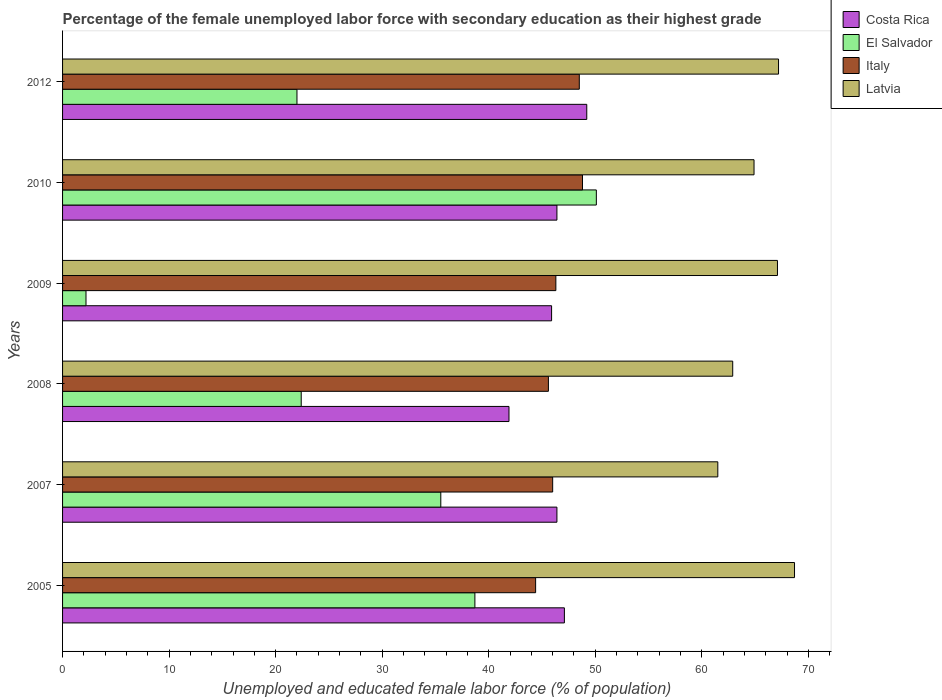Are the number of bars per tick equal to the number of legend labels?
Your answer should be very brief. Yes. What is the percentage of the unemployed female labor force with secondary education in El Salvador in 2007?
Provide a short and direct response. 35.5. Across all years, what is the maximum percentage of the unemployed female labor force with secondary education in Costa Rica?
Your answer should be compact. 49.2. Across all years, what is the minimum percentage of the unemployed female labor force with secondary education in El Salvador?
Provide a succinct answer. 2.2. In which year was the percentage of the unemployed female labor force with secondary education in Latvia maximum?
Offer a terse response. 2005. In which year was the percentage of the unemployed female labor force with secondary education in El Salvador minimum?
Your answer should be compact. 2009. What is the total percentage of the unemployed female labor force with secondary education in Italy in the graph?
Ensure brevity in your answer.  279.6. What is the difference between the percentage of the unemployed female labor force with secondary education in El Salvador in 2007 and that in 2010?
Your answer should be compact. -14.6. What is the difference between the percentage of the unemployed female labor force with secondary education in Latvia in 2010 and the percentage of the unemployed female labor force with secondary education in El Salvador in 2007?
Offer a very short reply. 29.4. What is the average percentage of the unemployed female labor force with secondary education in Costa Rica per year?
Offer a terse response. 46.15. In the year 2007, what is the difference between the percentage of the unemployed female labor force with secondary education in Latvia and percentage of the unemployed female labor force with secondary education in Italy?
Make the answer very short. 15.5. What is the ratio of the percentage of the unemployed female labor force with secondary education in El Salvador in 2005 to that in 2007?
Ensure brevity in your answer.  1.09. Is the percentage of the unemployed female labor force with secondary education in El Salvador in 2010 less than that in 2012?
Provide a succinct answer. No. Is the difference between the percentage of the unemployed female labor force with secondary education in Latvia in 2010 and 2012 greater than the difference between the percentage of the unemployed female labor force with secondary education in Italy in 2010 and 2012?
Offer a terse response. No. What is the difference between the highest and the second highest percentage of the unemployed female labor force with secondary education in Italy?
Your response must be concise. 0.3. What is the difference between the highest and the lowest percentage of the unemployed female labor force with secondary education in El Salvador?
Provide a short and direct response. 47.9. Is the sum of the percentage of the unemployed female labor force with secondary education in Italy in 2009 and 2012 greater than the maximum percentage of the unemployed female labor force with secondary education in Costa Rica across all years?
Your answer should be very brief. Yes. Is it the case that in every year, the sum of the percentage of the unemployed female labor force with secondary education in Costa Rica and percentage of the unemployed female labor force with secondary education in Italy is greater than the sum of percentage of the unemployed female labor force with secondary education in El Salvador and percentage of the unemployed female labor force with secondary education in Latvia?
Your answer should be very brief. No. What does the 3rd bar from the top in 2007 represents?
Give a very brief answer. El Salvador. What does the 4th bar from the bottom in 2007 represents?
Offer a terse response. Latvia. How many bars are there?
Offer a very short reply. 24. What is the difference between two consecutive major ticks on the X-axis?
Give a very brief answer. 10. Are the values on the major ticks of X-axis written in scientific E-notation?
Give a very brief answer. No. How many legend labels are there?
Your response must be concise. 4. What is the title of the graph?
Ensure brevity in your answer.  Percentage of the female unemployed labor force with secondary education as their highest grade. Does "Seychelles" appear as one of the legend labels in the graph?
Give a very brief answer. No. What is the label or title of the X-axis?
Your response must be concise. Unemployed and educated female labor force (% of population). What is the Unemployed and educated female labor force (% of population) of Costa Rica in 2005?
Your answer should be very brief. 47.1. What is the Unemployed and educated female labor force (% of population) in El Salvador in 2005?
Your answer should be very brief. 38.7. What is the Unemployed and educated female labor force (% of population) in Italy in 2005?
Your answer should be compact. 44.4. What is the Unemployed and educated female labor force (% of population) of Latvia in 2005?
Your response must be concise. 68.7. What is the Unemployed and educated female labor force (% of population) of Costa Rica in 2007?
Your answer should be compact. 46.4. What is the Unemployed and educated female labor force (% of population) of El Salvador in 2007?
Give a very brief answer. 35.5. What is the Unemployed and educated female labor force (% of population) of Italy in 2007?
Your answer should be compact. 46. What is the Unemployed and educated female labor force (% of population) in Latvia in 2007?
Keep it short and to the point. 61.5. What is the Unemployed and educated female labor force (% of population) of Costa Rica in 2008?
Your answer should be very brief. 41.9. What is the Unemployed and educated female labor force (% of population) in El Salvador in 2008?
Your answer should be compact. 22.4. What is the Unemployed and educated female labor force (% of population) in Italy in 2008?
Your answer should be compact. 45.6. What is the Unemployed and educated female labor force (% of population) in Latvia in 2008?
Keep it short and to the point. 62.9. What is the Unemployed and educated female labor force (% of population) in Costa Rica in 2009?
Ensure brevity in your answer.  45.9. What is the Unemployed and educated female labor force (% of population) in El Salvador in 2009?
Give a very brief answer. 2.2. What is the Unemployed and educated female labor force (% of population) of Italy in 2009?
Provide a succinct answer. 46.3. What is the Unemployed and educated female labor force (% of population) in Latvia in 2009?
Your answer should be compact. 67.1. What is the Unemployed and educated female labor force (% of population) in Costa Rica in 2010?
Keep it short and to the point. 46.4. What is the Unemployed and educated female labor force (% of population) in El Salvador in 2010?
Your answer should be compact. 50.1. What is the Unemployed and educated female labor force (% of population) of Italy in 2010?
Provide a short and direct response. 48.8. What is the Unemployed and educated female labor force (% of population) in Latvia in 2010?
Your answer should be very brief. 64.9. What is the Unemployed and educated female labor force (% of population) of Costa Rica in 2012?
Give a very brief answer. 49.2. What is the Unemployed and educated female labor force (% of population) in El Salvador in 2012?
Give a very brief answer. 22. What is the Unemployed and educated female labor force (% of population) in Italy in 2012?
Ensure brevity in your answer.  48.5. What is the Unemployed and educated female labor force (% of population) in Latvia in 2012?
Your answer should be very brief. 67.2. Across all years, what is the maximum Unemployed and educated female labor force (% of population) in Costa Rica?
Offer a very short reply. 49.2. Across all years, what is the maximum Unemployed and educated female labor force (% of population) in El Salvador?
Your response must be concise. 50.1. Across all years, what is the maximum Unemployed and educated female labor force (% of population) in Italy?
Keep it short and to the point. 48.8. Across all years, what is the maximum Unemployed and educated female labor force (% of population) in Latvia?
Your response must be concise. 68.7. Across all years, what is the minimum Unemployed and educated female labor force (% of population) of Costa Rica?
Your response must be concise. 41.9. Across all years, what is the minimum Unemployed and educated female labor force (% of population) of El Salvador?
Your answer should be very brief. 2.2. Across all years, what is the minimum Unemployed and educated female labor force (% of population) in Italy?
Make the answer very short. 44.4. Across all years, what is the minimum Unemployed and educated female labor force (% of population) in Latvia?
Your response must be concise. 61.5. What is the total Unemployed and educated female labor force (% of population) in Costa Rica in the graph?
Your answer should be compact. 276.9. What is the total Unemployed and educated female labor force (% of population) in El Salvador in the graph?
Offer a terse response. 170.9. What is the total Unemployed and educated female labor force (% of population) in Italy in the graph?
Your answer should be very brief. 279.6. What is the total Unemployed and educated female labor force (% of population) of Latvia in the graph?
Offer a terse response. 392.3. What is the difference between the Unemployed and educated female labor force (% of population) in Costa Rica in 2005 and that in 2007?
Offer a terse response. 0.7. What is the difference between the Unemployed and educated female labor force (% of population) of Italy in 2005 and that in 2007?
Keep it short and to the point. -1.6. What is the difference between the Unemployed and educated female labor force (% of population) in El Salvador in 2005 and that in 2008?
Make the answer very short. 16.3. What is the difference between the Unemployed and educated female labor force (% of population) in El Salvador in 2005 and that in 2009?
Ensure brevity in your answer.  36.5. What is the difference between the Unemployed and educated female labor force (% of population) in Italy in 2005 and that in 2009?
Your answer should be compact. -1.9. What is the difference between the Unemployed and educated female labor force (% of population) in Italy in 2005 and that in 2010?
Offer a very short reply. -4.4. What is the difference between the Unemployed and educated female labor force (% of population) in Italy in 2007 and that in 2008?
Provide a succinct answer. 0.4. What is the difference between the Unemployed and educated female labor force (% of population) of Costa Rica in 2007 and that in 2009?
Provide a succinct answer. 0.5. What is the difference between the Unemployed and educated female labor force (% of population) in El Salvador in 2007 and that in 2009?
Your answer should be compact. 33.3. What is the difference between the Unemployed and educated female labor force (% of population) in Costa Rica in 2007 and that in 2010?
Your answer should be compact. 0. What is the difference between the Unemployed and educated female labor force (% of population) of El Salvador in 2007 and that in 2010?
Your answer should be very brief. -14.6. What is the difference between the Unemployed and educated female labor force (% of population) of Costa Rica in 2007 and that in 2012?
Your answer should be compact. -2.8. What is the difference between the Unemployed and educated female labor force (% of population) in Italy in 2007 and that in 2012?
Keep it short and to the point. -2.5. What is the difference between the Unemployed and educated female labor force (% of population) in El Salvador in 2008 and that in 2009?
Your answer should be very brief. 20.2. What is the difference between the Unemployed and educated female labor force (% of population) of El Salvador in 2008 and that in 2010?
Give a very brief answer. -27.7. What is the difference between the Unemployed and educated female labor force (% of population) in El Salvador in 2008 and that in 2012?
Offer a terse response. 0.4. What is the difference between the Unemployed and educated female labor force (% of population) in Italy in 2008 and that in 2012?
Your answer should be compact. -2.9. What is the difference between the Unemployed and educated female labor force (% of population) of Latvia in 2008 and that in 2012?
Make the answer very short. -4.3. What is the difference between the Unemployed and educated female labor force (% of population) of El Salvador in 2009 and that in 2010?
Your answer should be compact. -47.9. What is the difference between the Unemployed and educated female labor force (% of population) in El Salvador in 2009 and that in 2012?
Your response must be concise. -19.8. What is the difference between the Unemployed and educated female labor force (% of population) in Latvia in 2009 and that in 2012?
Offer a very short reply. -0.1. What is the difference between the Unemployed and educated female labor force (% of population) in Costa Rica in 2010 and that in 2012?
Your answer should be compact. -2.8. What is the difference between the Unemployed and educated female labor force (% of population) in El Salvador in 2010 and that in 2012?
Your answer should be compact. 28.1. What is the difference between the Unemployed and educated female labor force (% of population) in Italy in 2010 and that in 2012?
Give a very brief answer. 0.3. What is the difference between the Unemployed and educated female labor force (% of population) in Costa Rica in 2005 and the Unemployed and educated female labor force (% of population) in El Salvador in 2007?
Your response must be concise. 11.6. What is the difference between the Unemployed and educated female labor force (% of population) in Costa Rica in 2005 and the Unemployed and educated female labor force (% of population) in Italy in 2007?
Your response must be concise. 1.1. What is the difference between the Unemployed and educated female labor force (% of population) in Costa Rica in 2005 and the Unemployed and educated female labor force (% of population) in Latvia in 2007?
Provide a short and direct response. -14.4. What is the difference between the Unemployed and educated female labor force (% of population) in El Salvador in 2005 and the Unemployed and educated female labor force (% of population) in Italy in 2007?
Your response must be concise. -7.3. What is the difference between the Unemployed and educated female labor force (% of population) in El Salvador in 2005 and the Unemployed and educated female labor force (% of population) in Latvia in 2007?
Provide a short and direct response. -22.8. What is the difference between the Unemployed and educated female labor force (% of population) of Italy in 2005 and the Unemployed and educated female labor force (% of population) of Latvia in 2007?
Your answer should be very brief. -17.1. What is the difference between the Unemployed and educated female labor force (% of population) of Costa Rica in 2005 and the Unemployed and educated female labor force (% of population) of El Salvador in 2008?
Keep it short and to the point. 24.7. What is the difference between the Unemployed and educated female labor force (% of population) in Costa Rica in 2005 and the Unemployed and educated female labor force (% of population) in Latvia in 2008?
Offer a very short reply. -15.8. What is the difference between the Unemployed and educated female labor force (% of population) of El Salvador in 2005 and the Unemployed and educated female labor force (% of population) of Latvia in 2008?
Keep it short and to the point. -24.2. What is the difference between the Unemployed and educated female labor force (% of population) in Italy in 2005 and the Unemployed and educated female labor force (% of population) in Latvia in 2008?
Give a very brief answer. -18.5. What is the difference between the Unemployed and educated female labor force (% of population) of Costa Rica in 2005 and the Unemployed and educated female labor force (% of population) of El Salvador in 2009?
Ensure brevity in your answer.  44.9. What is the difference between the Unemployed and educated female labor force (% of population) in Costa Rica in 2005 and the Unemployed and educated female labor force (% of population) in Italy in 2009?
Make the answer very short. 0.8. What is the difference between the Unemployed and educated female labor force (% of population) of Costa Rica in 2005 and the Unemployed and educated female labor force (% of population) of Latvia in 2009?
Give a very brief answer. -20. What is the difference between the Unemployed and educated female labor force (% of population) in El Salvador in 2005 and the Unemployed and educated female labor force (% of population) in Latvia in 2009?
Offer a terse response. -28.4. What is the difference between the Unemployed and educated female labor force (% of population) in Italy in 2005 and the Unemployed and educated female labor force (% of population) in Latvia in 2009?
Give a very brief answer. -22.7. What is the difference between the Unemployed and educated female labor force (% of population) in Costa Rica in 2005 and the Unemployed and educated female labor force (% of population) in Latvia in 2010?
Offer a terse response. -17.8. What is the difference between the Unemployed and educated female labor force (% of population) of El Salvador in 2005 and the Unemployed and educated female labor force (% of population) of Latvia in 2010?
Ensure brevity in your answer.  -26.2. What is the difference between the Unemployed and educated female labor force (% of population) in Italy in 2005 and the Unemployed and educated female labor force (% of population) in Latvia in 2010?
Give a very brief answer. -20.5. What is the difference between the Unemployed and educated female labor force (% of population) of Costa Rica in 2005 and the Unemployed and educated female labor force (% of population) of El Salvador in 2012?
Your answer should be very brief. 25.1. What is the difference between the Unemployed and educated female labor force (% of population) in Costa Rica in 2005 and the Unemployed and educated female labor force (% of population) in Italy in 2012?
Provide a succinct answer. -1.4. What is the difference between the Unemployed and educated female labor force (% of population) of Costa Rica in 2005 and the Unemployed and educated female labor force (% of population) of Latvia in 2012?
Offer a very short reply. -20.1. What is the difference between the Unemployed and educated female labor force (% of population) of El Salvador in 2005 and the Unemployed and educated female labor force (% of population) of Latvia in 2012?
Provide a succinct answer. -28.5. What is the difference between the Unemployed and educated female labor force (% of population) in Italy in 2005 and the Unemployed and educated female labor force (% of population) in Latvia in 2012?
Provide a short and direct response. -22.8. What is the difference between the Unemployed and educated female labor force (% of population) of Costa Rica in 2007 and the Unemployed and educated female labor force (% of population) of Italy in 2008?
Your answer should be very brief. 0.8. What is the difference between the Unemployed and educated female labor force (% of population) in Costa Rica in 2007 and the Unemployed and educated female labor force (% of population) in Latvia in 2008?
Your answer should be very brief. -16.5. What is the difference between the Unemployed and educated female labor force (% of population) in El Salvador in 2007 and the Unemployed and educated female labor force (% of population) in Latvia in 2008?
Your answer should be very brief. -27.4. What is the difference between the Unemployed and educated female labor force (% of population) of Italy in 2007 and the Unemployed and educated female labor force (% of population) of Latvia in 2008?
Your answer should be compact. -16.9. What is the difference between the Unemployed and educated female labor force (% of population) in Costa Rica in 2007 and the Unemployed and educated female labor force (% of population) in El Salvador in 2009?
Provide a short and direct response. 44.2. What is the difference between the Unemployed and educated female labor force (% of population) in Costa Rica in 2007 and the Unemployed and educated female labor force (% of population) in Latvia in 2009?
Keep it short and to the point. -20.7. What is the difference between the Unemployed and educated female labor force (% of population) of El Salvador in 2007 and the Unemployed and educated female labor force (% of population) of Italy in 2009?
Provide a succinct answer. -10.8. What is the difference between the Unemployed and educated female labor force (% of population) of El Salvador in 2007 and the Unemployed and educated female labor force (% of population) of Latvia in 2009?
Offer a terse response. -31.6. What is the difference between the Unemployed and educated female labor force (% of population) in Italy in 2007 and the Unemployed and educated female labor force (% of population) in Latvia in 2009?
Your answer should be compact. -21.1. What is the difference between the Unemployed and educated female labor force (% of population) in Costa Rica in 2007 and the Unemployed and educated female labor force (% of population) in El Salvador in 2010?
Offer a very short reply. -3.7. What is the difference between the Unemployed and educated female labor force (% of population) in Costa Rica in 2007 and the Unemployed and educated female labor force (% of population) in Latvia in 2010?
Your response must be concise. -18.5. What is the difference between the Unemployed and educated female labor force (% of population) in El Salvador in 2007 and the Unemployed and educated female labor force (% of population) in Latvia in 2010?
Make the answer very short. -29.4. What is the difference between the Unemployed and educated female labor force (% of population) of Italy in 2007 and the Unemployed and educated female labor force (% of population) of Latvia in 2010?
Your answer should be compact. -18.9. What is the difference between the Unemployed and educated female labor force (% of population) in Costa Rica in 2007 and the Unemployed and educated female labor force (% of population) in El Salvador in 2012?
Give a very brief answer. 24.4. What is the difference between the Unemployed and educated female labor force (% of population) in Costa Rica in 2007 and the Unemployed and educated female labor force (% of population) in Latvia in 2012?
Give a very brief answer. -20.8. What is the difference between the Unemployed and educated female labor force (% of population) in El Salvador in 2007 and the Unemployed and educated female labor force (% of population) in Italy in 2012?
Your answer should be very brief. -13. What is the difference between the Unemployed and educated female labor force (% of population) in El Salvador in 2007 and the Unemployed and educated female labor force (% of population) in Latvia in 2012?
Give a very brief answer. -31.7. What is the difference between the Unemployed and educated female labor force (% of population) of Italy in 2007 and the Unemployed and educated female labor force (% of population) of Latvia in 2012?
Offer a very short reply. -21.2. What is the difference between the Unemployed and educated female labor force (% of population) in Costa Rica in 2008 and the Unemployed and educated female labor force (% of population) in El Salvador in 2009?
Make the answer very short. 39.7. What is the difference between the Unemployed and educated female labor force (% of population) of Costa Rica in 2008 and the Unemployed and educated female labor force (% of population) of Latvia in 2009?
Your answer should be compact. -25.2. What is the difference between the Unemployed and educated female labor force (% of population) in El Salvador in 2008 and the Unemployed and educated female labor force (% of population) in Italy in 2009?
Your response must be concise. -23.9. What is the difference between the Unemployed and educated female labor force (% of population) of El Salvador in 2008 and the Unemployed and educated female labor force (% of population) of Latvia in 2009?
Ensure brevity in your answer.  -44.7. What is the difference between the Unemployed and educated female labor force (% of population) in Italy in 2008 and the Unemployed and educated female labor force (% of population) in Latvia in 2009?
Your answer should be compact. -21.5. What is the difference between the Unemployed and educated female labor force (% of population) in Costa Rica in 2008 and the Unemployed and educated female labor force (% of population) in El Salvador in 2010?
Your response must be concise. -8.2. What is the difference between the Unemployed and educated female labor force (% of population) in Costa Rica in 2008 and the Unemployed and educated female labor force (% of population) in Italy in 2010?
Offer a very short reply. -6.9. What is the difference between the Unemployed and educated female labor force (% of population) in El Salvador in 2008 and the Unemployed and educated female labor force (% of population) in Italy in 2010?
Offer a terse response. -26.4. What is the difference between the Unemployed and educated female labor force (% of population) of El Salvador in 2008 and the Unemployed and educated female labor force (% of population) of Latvia in 2010?
Your answer should be compact. -42.5. What is the difference between the Unemployed and educated female labor force (% of population) in Italy in 2008 and the Unemployed and educated female labor force (% of population) in Latvia in 2010?
Keep it short and to the point. -19.3. What is the difference between the Unemployed and educated female labor force (% of population) in Costa Rica in 2008 and the Unemployed and educated female labor force (% of population) in El Salvador in 2012?
Your answer should be very brief. 19.9. What is the difference between the Unemployed and educated female labor force (% of population) of Costa Rica in 2008 and the Unemployed and educated female labor force (% of population) of Italy in 2012?
Offer a terse response. -6.6. What is the difference between the Unemployed and educated female labor force (% of population) in Costa Rica in 2008 and the Unemployed and educated female labor force (% of population) in Latvia in 2012?
Offer a terse response. -25.3. What is the difference between the Unemployed and educated female labor force (% of population) of El Salvador in 2008 and the Unemployed and educated female labor force (% of population) of Italy in 2012?
Give a very brief answer. -26.1. What is the difference between the Unemployed and educated female labor force (% of population) of El Salvador in 2008 and the Unemployed and educated female labor force (% of population) of Latvia in 2012?
Keep it short and to the point. -44.8. What is the difference between the Unemployed and educated female labor force (% of population) in Italy in 2008 and the Unemployed and educated female labor force (% of population) in Latvia in 2012?
Your answer should be compact. -21.6. What is the difference between the Unemployed and educated female labor force (% of population) in Costa Rica in 2009 and the Unemployed and educated female labor force (% of population) in Italy in 2010?
Offer a terse response. -2.9. What is the difference between the Unemployed and educated female labor force (% of population) of Costa Rica in 2009 and the Unemployed and educated female labor force (% of population) of Latvia in 2010?
Make the answer very short. -19. What is the difference between the Unemployed and educated female labor force (% of population) of El Salvador in 2009 and the Unemployed and educated female labor force (% of population) of Italy in 2010?
Your answer should be very brief. -46.6. What is the difference between the Unemployed and educated female labor force (% of population) in El Salvador in 2009 and the Unemployed and educated female labor force (% of population) in Latvia in 2010?
Give a very brief answer. -62.7. What is the difference between the Unemployed and educated female labor force (% of population) in Italy in 2009 and the Unemployed and educated female labor force (% of population) in Latvia in 2010?
Offer a very short reply. -18.6. What is the difference between the Unemployed and educated female labor force (% of population) of Costa Rica in 2009 and the Unemployed and educated female labor force (% of population) of El Salvador in 2012?
Your answer should be compact. 23.9. What is the difference between the Unemployed and educated female labor force (% of population) in Costa Rica in 2009 and the Unemployed and educated female labor force (% of population) in Latvia in 2012?
Ensure brevity in your answer.  -21.3. What is the difference between the Unemployed and educated female labor force (% of population) of El Salvador in 2009 and the Unemployed and educated female labor force (% of population) of Italy in 2012?
Give a very brief answer. -46.3. What is the difference between the Unemployed and educated female labor force (% of population) of El Salvador in 2009 and the Unemployed and educated female labor force (% of population) of Latvia in 2012?
Offer a very short reply. -65. What is the difference between the Unemployed and educated female labor force (% of population) in Italy in 2009 and the Unemployed and educated female labor force (% of population) in Latvia in 2012?
Provide a succinct answer. -20.9. What is the difference between the Unemployed and educated female labor force (% of population) of Costa Rica in 2010 and the Unemployed and educated female labor force (% of population) of El Salvador in 2012?
Make the answer very short. 24.4. What is the difference between the Unemployed and educated female labor force (% of population) in Costa Rica in 2010 and the Unemployed and educated female labor force (% of population) in Italy in 2012?
Your answer should be compact. -2.1. What is the difference between the Unemployed and educated female labor force (% of population) in Costa Rica in 2010 and the Unemployed and educated female labor force (% of population) in Latvia in 2012?
Make the answer very short. -20.8. What is the difference between the Unemployed and educated female labor force (% of population) of El Salvador in 2010 and the Unemployed and educated female labor force (% of population) of Latvia in 2012?
Your response must be concise. -17.1. What is the difference between the Unemployed and educated female labor force (% of population) in Italy in 2010 and the Unemployed and educated female labor force (% of population) in Latvia in 2012?
Offer a terse response. -18.4. What is the average Unemployed and educated female labor force (% of population) in Costa Rica per year?
Provide a succinct answer. 46.15. What is the average Unemployed and educated female labor force (% of population) of El Salvador per year?
Offer a very short reply. 28.48. What is the average Unemployed and educated female labor force (% of population) of Italy per year?
Your response must be concise. 46.6. What is the average Unemployed and educated female labor force (% of population) of Latvia per year?
Make the answer very short. 65.38. In the year 2005, what is the difference between the Unemployed and educated female labor force (% of population) in Costa Rica and Unemployed and educated female labor force (% of population) in El Salvador?
Give a very brief answer. 8.4. In the year 2005, what is the difference between the Unemployed and educated female labor force (% of population) in Costa Rica and Unemployed and educated female labor force (% of population) in Italy?
Ensure brevity in your answer.  2.7. In the year 2005, what is the difference between the Unemployed and educated female labor force (% of population) of Costa Rica and Unemployed and educated female labor force (% of population) of Latvia?
Offer a terse response. -21.6. In the year 2005, what is the difference between the Unemployed and educated female labor force (% of population) in El Salvador and Unemployed and educated female labor force (% of population) in Italy?
Offer a very short reply. -5.7. In the year 2005, what is the difference between the Unemployed and educated female labor force (% of population) in El Salvador and Unemployed and educated female labor force (% of population) in Latvia?
Provide a short and direct response. -30. In the year 2005, what is the difference between the Unemployed and educated female labor force (% of population) in Italy and Unemployed and educated female labor force (% of population) in Latvia?
Keep it short and to the point. -24.3. In the year 2007, what is the difference between the Unemployed and educated female labor force (% of population) of Costa Rica and Unemployed and educated female labor force (% of population) of El Salvador?
Offer a very short reply. 10.9. In the year 2007, what is the difference between the Unemployed and educated female labor force (% of population) in Costa Rica and Unemployed and educated female labor force (% of population) in Latvia?
Provide a succinct answer. -15.1. In the year 2007, what is the difference between the Unemployed and educated female labor force (% of population) in Italy and Unemployed and educated female labor force (% of population) in Latvia?
Offer a very short reply. -15.5. In the year 2008, what is the difference between the Unemployed and educated female labor force (% of population) of Costa Rica and Unemployed and educated female labor force (% of population) of Latvia?
Make the answer very short. -21. In the year 2008, what is the difference between the Unemployed and educated female labor force (% of population) of El Salvador and Unemployed and educated female labor force (% of population) of Italy?
Give a very brief answer. -23.2. In the year 2008, what is the difference between the Unemployed and educated female labor force (% of population) of El Salvador and Unemployed and educated female labor force (% of population) of Latvia?
Offer a very short reply. -40.5. In the year 2008, what is the difference between the Unemployed and educated female labor force (% of population) in Italy and Unemployed and educated female labor force (% of population) in Latvia?
Your response must be concise. -17.3. In the year 2009, what is the difference between the Unemployed and educated female labor force (% of population) of Costa Rica and Unemployed and educated female labor force (% of population) of El Salvador?
Offer a terse response. 43.7. In the year 2009, what is the difference between the Unemployed and educated female labor force (% of population) in Costa Rica and Unemployed and educated female labor force (% of population) in Italy?
Provide a short and direct response. -0.4. In the year 2009, what is the difference between the Unemployed and educated female labor force (% of population) of Costa Rica and Unemployed and educated female labor force (% of population) of Latvia?
Keep it short and to the point. -21.2. In the year 2009, what is the difference between the Unemployed and educated female labor force (% of population) of El Salvador and Unemployed and educated female labor force (% of population) of Italy?
Offer a terse response. -44.1. In the year 2009, what is the difference between the Unemployed and educated female labor force (% of population) in El Salvador and Unemployed and educated female labor force (% of population) in Latvia?
Your answer should be very brief. -64.9. In the year 2009, what is the difference between the Unemployed and educated female labor force (% of population) of Italy and Unemployed and educated female labor force (% of population) of Latvia?
Give a very brief answer. -20.8. In the year 2010, what is the difference between the Unemployed and educated female labor force (% of population) of Costa Rica and Unemployed and educated female labor force (% of population) of Italy?
Keep it short and to the point. -2.4. In the year 2010, what is the difference between the Unemployed and educated female labor force (% of population) in Costa Rica and Unemployed and educated female labor force (% of population) in Latvia?
Make the answer very short. -18.5. In the year 2010, what is the difference between the Unemployed and educated female labor force (% of population) of El Salvador and Unemployed and educated female labor force (% of population) of Latvia?
Ensure brevity in your answer.  -14.8. In the year 2010, what is the difference between the Unemployed and educated female labor force (% of population) in Italy and Unemployed and educated female labor force (% of population) in Latvia?
Make the answer very short. -16.1. In the year 2012, what is the difference between the Unemployed and educated female labor force (% of population) in Costa Rica and Unemployed and educated female labor force (% of population) in El Salvador?
Your answer should be very brief. 27.2. In the year 2012, what is the difference between the Unemployed and educated female labor force (% of population) of Costa Rica and Unemployed and educated female labor force (% of population) of Italy?
Make the answer very short. 0.7. In the year 2012, what is the difference between the Unemployed and educated female labor force (% of population) of Costa Rica and Unemployed and educated female labor force (% of population) of Latvia?
Give a very brief answer. -18. In the year 2012, what is the difference between the Unemployed and educated female labor force (% of population) of El Salvador and Unemployed and educated female labor force (% of population) of Italy?
Ensure brevity in your answer.  -26.5. In the year 2012, what is the difference between the Unemployed and educated female labor force (% of population) in El Salvador and Unemployed and educated female labor force (% of population) in Latvia?
Your response must be concise. -45.2. In the year 2012, what is the difference between the Unemployed and educated female labor force (% of population) in Italy and Unemployed and educated female labor force (% of population) in Latvia?
Give a very brief answer. -18.7. What is the ratio of the Unemployed and educated female labor force (% of population) of Costa Rica in 2005 to that in 2007?
Your answer should be very brief. 1.02. What is the ratio of the Unemployed and educated female labor force (% of population) in El Salvador in 2005 to that in 2007?
Provide a succinct answer. 1.09. What is the ratio of the Unemployed and educated female labor force (% of population) of Italy in 2005 to that in 2007?
Ensure brevity in your answer.  0.97. What is the ratio of the Unemployed and educated female labor force (% of population) in Latvia in 2005 to that in 2007?
Your answer should be compact. 1.12. What is the ratio of the Unemployed and educated female labor force (% of population) in Costa Rica in 2005 to that in 2008?
Ensure brevity in your answer.  1.12. What is the ratio of the Unemployed and educated female labor force (% of population) of El Salvador in 2005 to that in 2008?
Keep it short and to the point. 1.73. What is the ratio of the Unemployed and educated female labor force (% of population) in Italy in 2005 to that in 2008?
Your answer should be compact. 0.97. What is the ratio of the Unemployed and educated female labor force (% of population) in Latvia in 2005 to that in 2008?
Keep it short and to the point. 1.09. What is the ratio of the Unemployed and educated female labor force (% of population) of Costa Rica in 2005 to that in 2009?
Ensure brevity in your answer.  1.03. What is the ratio of the Unemployed and educated female labor force (% of population) in El Salvador in 2005 to that in 2009?
Provide a succinct answer. 17.59. What is the ratio of the Unemployed and educated female labor force (% of population) of Latvia in 2005 to that in 2009?
Ensure brevity in your answer.  1.02. What is the ratio of the Unemployed and educated female labor force (% of population) of Costa Rica in 2005 to that in 2010?
Give a very brief answer. 1.02. What is the ratio of the Unemployed and educated female labor force (% of population) of El Salvador in 2005 to that in 2010?
Provide a succinct answer. 0.77. What is the ratio of the Unemployed and educated female labor force (% of population) of Italy in 2005 to that in 2010?
Your answer should be very brief. 0.91. What is the ratio of the Unemployed and educated female labor force (% of population) in Latvia in 2005 to that in 2010?
Provide a short and direct response. 1.06. What is the ratio of the Unemployed and educated female labor force (% of population) of Costa Rica in 2005 to that in 2012?
Give a very brief answer. 0.96. What is the ratio of the Unemployed and educated female labor force (% of population) of El Salvador in 2005 to that in 2012?
Your response must be concise. 1.76. What is the ratio of the Unemployed and educated female labor force (% of population) of Italy in 2005 to that in 2012?
Provide a succinct answer. 0.92. What is the ratio of the Unemployed and educated female labor force (% of population) of Latvia in 2005 to that in 2012?
Make the answer very short. 1.02. What is the ratio of the Unemployed and educated female labor force (% of population) of Costa Rica in 2007 to that in 2008?
Give a very brief answer. 1.11. What is the ratio of the Unemployed and educated female labor force (% of population) of El Salvador in 2007 to that in 2008?
Your answer should be compact. 1.58. What is the ratio of the Unemployed and educated female labor force (% of population) in Italy in 2007 to that in 2008?
Your answer should be compact. 1.01. What is the ratio of the Unemployed and educated female labor force (% of population) in Latvia in 2007 to that in 2008?
Provide a succinct answer. 0.98. What is the ratio of the Unemployed and educated female labor force (% of population) in Costa Rica in 2007 to that in 2009?
Make the answer very short. 1.01. What is the ratio of the Unemployed and educated female labor force (% of population) in El Salvador in 2007 to that in 2009?
Keep it short and to the point. 16.14. What is the ratio of the Unemployed and educated female labor force (% of population) in Italy in 2007 to that in 2009?
Make the answer very short. 0.99. What is the ratio of the Unemployed and educated female labor force (% of population) in Latvia in 2007 to that in 2009?
Offer a very short reply. 0.92. What is the ratio of the Unemployed and educated female labor force (% of population) of El Salvador in 2007 to that in 2010?
Give a very brief answer. 0.71. What is the ratio of the Unemployed and educated female labor force (% of population) of Italy in 2007 to that in 2010?
Ensure brevity in your answer.  0.94. What is the ratio of the Unemployed and educated female labor force (% of population) in Latvia in 2007 to that in 2010?
Make the answer very short. 0.95. What is the ratio of the Unemployed and educated female labor force (% of population) of Costa Rica in 2007 to that in 2012?
Your response must be concise. 0.94. What is the ratio of the Unemployed and educated female labor force (% of population) of El Salvador in 2007 to that in 2012?
Your answer should be compact. 1.61. What is the ratio of the Unemployed and educated female labor force (% of population) in Italy in 2007 to that in 2012?
Provide a short and direct response. 0.95. What is the ratio of the Unemployed and educated female labor force (% of population) in Latvia in 2007 to that in 2012?
Provide a succinct answer. 0.92. What is the ratio of the Unemployed and educated female labor force (% of population) of Costa Rica in 2008 to that in 2009?
Make the answer very short. 0.91. What is the ratio of the Unemployed and educated female labor force (% of population) of El Salvador in 2008 to that in 2009?
Your answer should be compact. 10.18. What is the ratio of the Unemployed and educated female labor force (% of population) of Italy in 2008 to that in 2009?
Offer a very short reply. 0.98. What is the ratio of the Unemployed and educated female labor force (% of population) in Latvia in 2008 to that in 2009?
Ensure brevity in your answer.  0.94. What is the ratio of the Unemployed and educated female labor force (% of population) of Costa Rica in 2008 to that in 2010?
Offer a terse response. 0.9. What is the ratio of the Unemployed and educated female labor force (% of population) of El Salvador in 2008 to that in 2010?
Provide a succinct answer. 0.45. What is the ratio of the Unemployed and educated female labor force (% of population) of Italy in 2008 to that in 2010?
Provide a succinct answer. 0.93. What is the ratio of the Unemployed and educated female labor force (% of population) of Latvia in 2008 to that in 2010?
Give a very brief answer. 0.97. What is the ratio of the Unemployed and educated female labor force (% of population) of Costa Rica in 2008 to that in 2012?
Offer a terse response. 0.85. What is the ratio of the Unemployed and educated female labor force (% of population) in El Salvador in 2008 to that in 2012?
Provide a short and direct response. 1.02. What is the ratio of the Unemployed and educated female labor force (% of population) of Italy in 2008 to that in 2012?
Offer a terse response. 0.94. What is the ratio of the Unemployed and educated female labor force (% of population) of Latvia in 2008 to that in 2012?
Offer a terse response. 0.94. What is the ratio of the Unemployed and educated female labor force (% of population) in El Salvador in 2009 to that in 2010?
Offer a terse response. 0.04. What is the ratio of the Unemployed and educated female labor force (% of population) of Italy in 2009 to that in 2010?
Your answer should be very brief. 0.95. What is the ratio of the Unemployed and educated female labor force (% of population) in Latvia in 2009 to that in 2010?
Your response must be concise. 1.03. What is the ratio of the Unemployed and educated female labor force (% of population) in Costa Rica in 2009 to that in 2012?
Give a very brief answer. 0.93. What is the ratio of the Unemployed and educated female labor force (% of population) of Italy in 2009 to that in 2012?
Your answer should be compact. 0.95. What is the ratio of the Unemployed and educated female labor force (% of population) in Costa Rica in 2010 to that in 2012?
Give a very brief answer. 0.94. What is the ratio of the Unemployed and educated female labor force (% of population) of El Salvador in 2010 to that in 2012?
Ensure brevity in your answer.  2.28. What is the ratio of the Unemployed and educated female labor force (% of population) in Latvia in 2010 to that in 2012?
Your answer should be very brief. 0.97. What is the difference between the highest and the second highest Unemployed and educated female labor force (% of population) of Costa Rica?
Provide a succinct answer. 2.1. What is the difference between the highest and the second highest Unemployed and educated female labor force (% of population) in El Salvador?
Your response must be concise. 11.4. What is the difference between the highest and the second highest Unemployed and educated female labor force (% of population) of Latvia?
Make the answer very short. 1.5. What is the difference between the highest and the lowest Unemployed and educated female labor force (% of population) of Costa Rica?
Keep it short and to the point. 7.3. What is the difference between the highest and the lowest Unemployed and educated female labor force (% of population) in El Salvador?
Make the answer very short. 47.9. What is the difference between the highest and the lowest Unemployed and educated female labor force (% of population) in Italy?
Offer a very short reply. 4.4. 